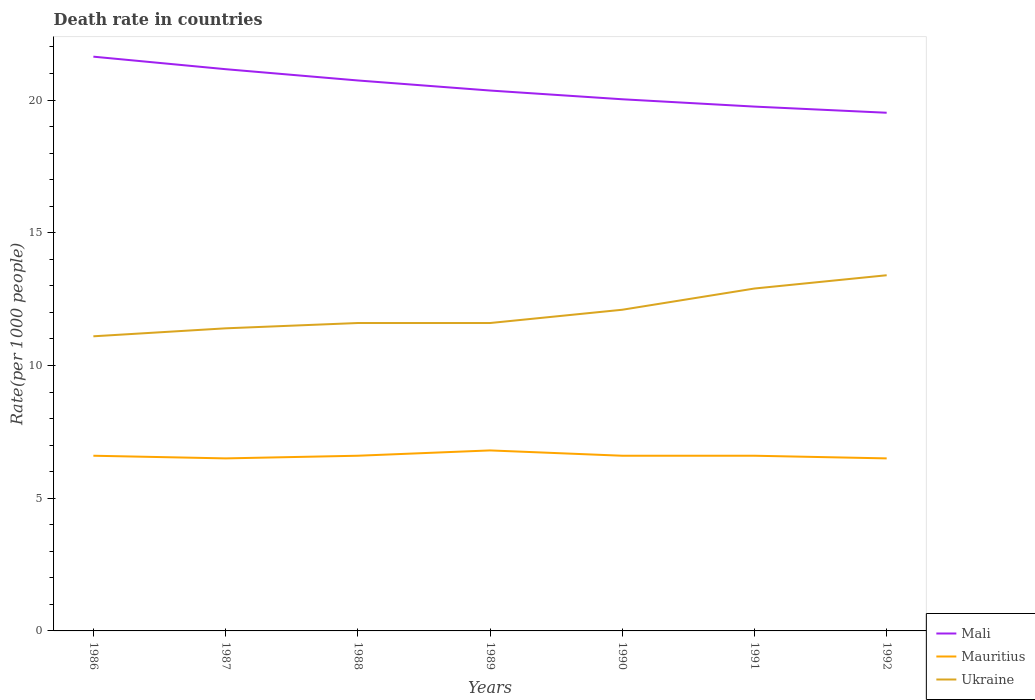Does the line corresponding to Mauritius intersect with the line corresponding to Mali?
Give a very brief answer. No. Across all years, what is the maximum death rate in Mali?
Keep it short and to the point. 19.52. In which year was the death rate in Mali maximum?
Keep it short and to the point. 1992. What is the total death rate in Mauritius in the graph?
Your answer should be very brief. 0.3. What is the difference between the highest and the second highest death rate in Mali?
Your answer should be compact. 2.11. What is the difference between two consecutive major ticks on the Y-axis?
Your answer should be very brief. 5. Are the values on the major ticks of Y-axis written in scientific E-notation?
Provide a short and direct response. No. Does the graph contain any zero values?
Your response must be concise. No. Does the graph contain grids?
Keep it short and to the point. No. Where does the legend appear in the graph?
Offer a very short reply. Bottom right. How many legend labels are there?
Ensure brevity in your answer.  3. How are the legend labels stacked?
Offer a very short reply. Vertical. What is the title of the graph?
Your answer should be compact. Death rate in countries. What is the label or title of the Y-axis?
Give a very brief answer. Rate(per 1000 people). What is the Rate(per 1000 people) of Mali in 1986?
Give a very brief answer. 21.64. What is the Rate(per 1000 people) in Ukraine in 1986?
Offer a terse response. 11.1. What is the Rate(per 1000 people) of Mali in 1987?
Make the answer very short. 21.16. What is the Rate(per 1000 people) of Mauritius in 1987?
Your answer should be very brief. 6.5. What is the Rate(per 1000 people) of Mali in 1988?
Your answer should be compact. 20.74. What is the Rate(per 1000 people) of Mauritius in 1988?
Provide a short and direct response. 6.6. What is the Rate(per 1000 people) of Ukraine in 1988?
Give a very brief answer. 11.6. What is the Rate(per 1000 people) of Mali in 1989?
Offer a very short reply. 20.36. What is the Rate(per 1000 people) of Mali in 1990?
Keep it short and to the point. 20.03. What is the Rate(per 1000 people) of Mali in 1991?
Keep it short and to the point. 19.75. What is the Rate(per 1000 people) of Mali in 1992?
Offer a very short reply. 19.52. What is the Rate(per 1000 people) of Mauritius in 1992?
Offer a very short reply. 6.5. What is the Rate(per 1000 people) in Ukraine in 1992?
Your response must be concise. 13.4. Across all years, what is the maximum Rate(per 1000 people) of Mali?
Provide a short and direct response. 21.64. Across all years, what is the maximum Rate(per 1000 people) of Mauritius?
Give a very brief answer. 6.8. Across all years, what is the maximum Rate(per 1000 people) in Ukraine?
Provide a short and direct response. 13.4. Across all years, what is the minimum Rate(per 1000 people) in Mali?
Make the answer very short. 19.52. Across all years, what is the minimum Rate(per 1000 people) of Mauritius?
Ensure brevity in your answer.  6.5. What is the total Rate(per 1000 people) in Mali in the graph?
Make the answer very short. 143.2. What is the total Rate(per 1000 people) of Mauritius in the graph?
Offer a terse response. 46.2. What is the total Rate(per 1000 people) of Ukraine in the graph?
Provide a succinct answer. 84.1. What is the difference between the Rate(per 1000 people) in Mali in 1986 and that in 1987?
Your answer should be very brief. 0.47. What is the difference between the Rate(per 1000 people) in Ukraine in 1986 and that in 1987?
Provide a short and direct response. -0.3. What is the difference between the Rate(per 1000 people) in Mali in 1986 and that in 1988?
Provide a succinct answer. 0.9. What is the difference between the Rate(per 1000 people) in Ukraine in 1986 and that in 1988?
Give a very brief answer. -0.5. What is the difference between the Rate(per 1000 people) in Mali in 1986 and that in 1989?
Your answer should be compact. 1.28. What is the difference between the Rate(per 1000 people) in Mali in 1986 and that in 1990?
Make the answer very short. 1.6. What is the difference between the Rate(per 1000 people) of Mali in 1986 and that in 1991?
Your response must be concise. 1.88. What is the difference between the Rate(per 1000 people) of Ukraine in 1986 and that in 1991?
Make the answer very short. -1.8. What is the difference between the Rate(per 1000 people) of Mali in 1986 and that in 1992?
Ensure brevity in your answer.  2.11. What is the difference between the Rate(per 1000 people) in Ukraine in 1986 and that in 1992?
Offer a very short reply. -2.3. What is the difference between the Rate(per 1000 people) in Mali in 1987 and that in 1988?
Provide a short and direct response. 0.42. What is the difference between the Rate(per 1000 people) of Mauritius in 1987 and that in 1988?
Provide a short and direct response. -0.1. What is the difference between the Rate(per 1000 people) in Mali in 1987 and that in 1989?
Offer a terse response. 0.8. What is the difference between the Rate(per 1000 people) in Mali in 1987 and that in 1990?
Offer a terse response. 1.13. What is the difference between the Rate(per 1000 people) in Mauritius in 1987 and that in 1990?
Give a very brief answer. -0.1. What is the difference between the Rate(per 1000 people) of Ukraine in 1987 and that in 1990?
Make the answer very short. -0.7. What is the difference between the Rate(per 1000 people) of Mali in 1987 and that in 1991?
Keep it short and to the point. 1.41. What is the difference between the Rate(per 1000 people) of Mauritius in 1987 and that in 1991?
Offer a terse response. -0.1. What is the difference between the Rate(per 1000 people) in Mali in 1987 and that in 1992?
Your answer should be very brief. 1.64. What is the difference between the Rate(per 1000 people) in Mauritius in 1987 and that in 1992?
Make the answer very short. 0. What is the difference between the Rate(per 1000 people) of Ukraine in 1987 and that in 1992?
Keep it short and to the point. -2. What is the difference between the Rate(per 1000 people) in Mali in 1988 and that in 1989?
Ensure brevity in your answer.  0.38. What is the difference between the Rate(per 1000 people) of Mauritius in 1988 and that in 1989?
Make the answer very short. -0.2. What is the difference between the Rate(per 1000 people) of Mali in 1988 and that in 1990?
Your answer should be compact. 0.71. What is the difference between the Rate(per 1000 people) of Mauritius in 1988 and that in 1990?
Ensure brevity in your answer.  0. What is the difference between the Rate(per 1000 people) in Ukraine in 1988 and that in 1990?
Offer a very short reply. -0.5. What is the difference between the Rate(per 1000 people) of Mauritius in 1988 and that in 1991?
Your answer should be very brief. 0. What is the difference between the Rate(per 1000 people) of Mali in 1988 and that in 1992?
Your response must be concise. 1.22. What is the difference between the Rate(per 1000 people) in Mauritius in 1988 and that in 1992?
Give a very brief answer. 0.1. What is the difference between the Rate(per 1000 people) in Mali in 1989 and that in 1990?
Provide a succinct answer. 0.33. What is the difference between the Rate(per 1000 people) in Mauritius in 1989 and that in 1990?
Make the answer very short. 0.2. What is the difference between the Rate(per 1000 people) of Mali in 1989 and that in 1991?
Your answer should be very brief. 0.6. What is the difference between the Rate(per 1000 people) in Ukraine in 1989 and that in 1991?
Keep it short and to the point. -1.3. What is the difference between the Rate(per 1000 people) in Mali in 1989 and that in 1992?
Offer a terse response. 0.84. What is the difference between the Rate(per 1000 people) in Mauritius in 1989 and that in 1992?
Offer a terse response. 0.3. What is the difference between the Rate(per 1000 people) in Ukraine in 1989 and that in 1992?
Your response must be concise. -1.8. What is the difference between the Rate(per 1000 people) of Mali in 1990 and that in 1991?
Your answer should be very brief. 0.28. What is the difference between the Rate(per 1000 people) of Mali in 1990 and that in 1992?
Your answer should be compact. 0.51. What is the difference between the Rate(per 1000 people) of Mauritius in 1990 and that in 1992?
Keep it short and to the point. 0.1. What is the difference between the Rate(per 1000 people) of Ukraine in 1990 and that in 1992?
Ensure brevity in your answer.  -1.3. What is the difference between the Rate(per 1000 people) in Mali in 1991 and that in 1992?
Give a very brief answer. 0.23. What is the difference between the Rate(per 1000 people) of Mauritius in 1991 and that in 1992?
Ensure brevity in your answer.  0.1. What is the difference between the Rate(per 1000 people) in Ukraine in 1991 and that in 1992?
Offer a very short reply. -0.5. What is the difference between the Rate(per 1000 people) in Mali in 1986 and the Rate(per 1000 people) in Mauritius in 1987?
Your response must be concise. 15.13. What is the difference between the Rate(per 1000 people) of Mali in 1986 and the Rate(per 1000 people) of Ukraine in 1987?
Your response must be concise. 10.23. What is the difference between the Rate(per 1000 people) in Mali in 1986 and the Rate(per 1000 people) in Mauritius in 1988?
Offer a terse response. 15.04. What is the difference between the Rate(per 1000 people) of Mali in 1986 and the Rate(per 1000 people) of Ukraine in 1988?
Your response must be concise. 10.04. What is the difference between the Rate(per 1000 people) of Mali in 1986 and the Rate(per 1000 people) of Mauritius in 1989?
Offer a terse response. 14.84. What is the difference between the Rate(per 1000 people) of Mali in 1986 and the Rate(per 1000 people) of Ukraine in 1989?
Keep it short and to the point. 10.04. What is the difference between the Rate(per 1000 people) in Mauritius in 1986 and the Rate(per 1000 people) in Ukraine in 1989?
Offer a very short reply. -5. What is the difference between the Rate(per 1000 people) in Mali in 1986 and the Rate(per 1000 people) in Mauritius in 1990?
Provide a short and direct response. 15.04. What is the difference between the Rate(per 1000 people) of Mali in 1986 and the Rate(per 1000 people) of Ukraine in 1990?
Make the answer very short. 9.54. What is the difference between the Rate(per 1000 people) of Mali in 1986 and the Rate(per 1000 people) of Mauritius in 1991?
Ensure brevity in your answer.  15.04. What is the difference between the Rate(per 1000 people) of Mali in 1986 and the Rate(per 1000 people) of Ukraine in 1991?
Your answer should be very brief. 8.73. What is the difference between the Rate(per 1000 people) in Mali in 1986 and the Rate(per 1000 people) in Mauritius in 1992?
Provide a succinct answer. 15.13. What is the difference between the Rate(per 1000 people) of Mali in 1986 and the Rate(per 1000 people) of Ukraine in 1992?
Keep it short and to the point. 8.23. What is the difference between the Rate(per 1000 people) of Mauritius in 1986 and the Rate(per 1000 people) of Ukraine in 1992?
Provide a short and direct response. -6.8. What is the difference between the Rate(per 1000 people) in Mali in 1987 and the Rate(per 1000 people) in Mauritius in 1988?
Ensure brevity in your answer.  14.56. What is the difference between the Rate(per 1000 people) in Mali in 1987 and the Rate(per 1000 people) in Ukraine in 1988?
Your answer should be compact. 9.56. What is the difference between the Rate(per 1000 people) in Mali in 1987 and the Rate(per 1000 people) in Mauritius in 1989?
Provide a short and direct response. 14.36. What is the difference between the Rate(per 1000 people) of Mali in 1987 and the Rate(per 1000 people) of Ukraine in 1989?
Provide a succinct answer. 9.56. What is the difference between the Rate(per 1000 people) of Mauritius in 1987 and the Rate(per 1000 people) of Ukraine in 1989?
Give a very brief answer. -5.1. What is the difference between the Rate(per 1000 people) in Mali in 1987 and the Rate(per 1000 people) in Mauritius in 1990?
Provide a short and direct response. 14.56. What is the difference between the Rate(per 1000 people) of Mali in 1987 and the Rate(per 1000 people) of Ukraine in 1990?
Your answer should be very brief. 9.06. What is the difference between the Rate(per 1000 people) of Mauritius in 1987 and the Rate(per 1000 people) of Ukraine in 1990?
Give a very brief answer. -5.6. What is the difference between the Rate(per 1000 people) of Mali in 1987 and the Rate(per 1000 people) of Mauritius in 1991?
Make the answer very short. 14.56. What is the difference between the Rate(per 1000 people) in Mali in 1987 and the Rate(per 1000 people) in Ukraine in 1991?
Your answer should be very brief. 8.26. What is the difference between the Rate(per 1000 people) in Mali in 1987 and the Rate(per 1000 people) in Mauritius in 1992?
Ensure brevity in your answer.  14.66. What is the difference between the Rate(per 1000 people) in Mali in 1987 and the Rate(per 1000 people) in Ukraine in 1992?
Keep it short and to the point. 7.76. What is the difference between the Rate(per 1000 people) in Mauritius in 1987 and the Rate(per 1000 people) in Ukraine in 1992?
Ensure brevity in your answer.  -6.9. What is the difference between the Rate(per 1000 people) in Mali in 1988 and the Rate(per 1000 people) in Mauritius in 1989?
Give a very brief answer. 13.94. What is the difference between the Rate(per 1000 people) in Mali in 1988 and the Rate(per 1000 people) in Ukraine in 1989?
Give a very brief answer. 9.14. What is the difference between the Rate(per 1000 people) of Mauritius in 1988 and the Rate(per 1000 people) of Ukraine in 1989?
Offer a terse response. -5. What is the difference between the Rate(per 1000 people) in Mali in 1988 and the Rate(per 1000 people) in Mauritius in 1990?
Provide a short and direct response. 14.14. What is the difference between the Rate(per 1000 people) in Mali in 1988 and the Rate(per 1000 people) in Ukraine in 1990?
Your answer should be compact. 8.64. What is the difference between the Rate(per 1000 people) of Mali in 1988 and the Rate(per 1000 people) of Mauritius in 1991?
Your answer should be compact. 14.14. What is the difference between the Rate(per 1000 people) in Mali in 1988 and the Rate(per 1000 people) in Ukraine in 1991?
Provide a short and direct response. 7.84. What is the difference between the Rate(per 1000 people) of Mauritius in 1988 and the Rate(per 1000 people) of Ukraine in 1991?
Offer a terse response. -6.3. What is the difference between the Rate(per 1000 people) of Mali in 1988 and the Rate(per 1000 people) of Mauritius in 1992?
Your response must be concise. 14.24. What is the difference between the Rate(per 1000 people) in Mali in 1988 and the Rate(per 1000 people) in Ukraine in 1992?
Give a very brief answer. 7.34. What is the difference between the Rate(per 1000 people) of Mali in 1989 and the Rate(per 1000 people) of Mauritius in 1990?
Make the answer very short. 13.76. What is the difference between the Rate(per 1000 people) of Mali in 1989 and the Rate(per 1000 people) of Ukraine in 1990?
Keep it short and to the point. 8.26. What is the difference between the Rate(per 1000 people) in Mali in 1989 and the Rate(per 1000 people) in Mauritius in 1991?
Your response must be concise. 13.76. What is the difference between the Rate(per 1000 people) of Mali in 1989 and the Rate(per 1000 people) of Ukraine in 1991?
Ensure brevity in your answer.  7.46. What is the difference between the Rate(per 1000 people) in Mali in 1989 and the Rate(per 1000 people) in Mauritius in 1992?
Make the answer very short. 13.86. What is the difference between the Rate(per 1000 people) of Mali in 1989 and the Rate(per 1000 people) of Ukraine in 1992?
Provide a short and direct response. 6.96. What is the difference between the Rate(per 1000 people) of Mauritius in 1989 and the Rate(per 1000 people) of Ukraine in 1992?
Your answer should be compact. -6.6. What is the difference between the Rate(per 1000 people) of Mali in 1990 and the Rate(per 1000 people) of Mauritius in 1991?
Give a very brief answer. 13.43. What is the difference between the Rate(per 1000 people) of Mali in 1990 and the Rate(per 1000 people) of Ukraine in 1991?
Your answer should be compact. 7.13. What is the difference between the Rate(per 1000 people) of Mauritius in 1990 and the Rate(per 1000 people) of Ukraine in 1991?
Provide a succinct answer. -6.3. What is the difference between the Rate(per 1000 people) in Mali in 1990 and the Rate(per 1000 people) in Mauritius in 1992?
Keep it short and to the point. 13.53. What is the difference between the Rate(per 1000 people) in Mali in 1990 and the Rate(per 1000 people) in Ukraine in 1992?
Your answer should be compact. 6.63. What is the difference between the Rate(per 1000 people) in Mauritius in 1990 and the Rate(per 1000 people) in Ukraine in 1992?
Give a very brief answer. -6.8. What is the difference between the Rate(per 1000 people) of Mali in 1991 and the Rate(per 1000 people) of Mauritius in 1992?
Your answer should be very brief. 13.25. What is the difference between the Rate(per 1000 people) of Mali in 1991 and the Rate(per 1000 people) of Ukraine in 1992?
Your response must be concise. 6.35. What is the average Rate(per 1000 people) in Mali per year?
Your answer should be very brief. 20.46. What is the average Rate(per 1000 people) in Ukraine per year?
Your answer should be compact. 12.01. In the year 1986, what is the difference between the Rate(per 1000 people) in Mali and Rate(per 1000 people) in Mauritius?
Keep it short and to the point. 15.04. In the year 1986, what is the difference between the Rate(per 1000 people) in Mali and Rate(per 1000 people) in Ukraine?
Your answer should be compact. 10.54. In the year 1986, what is the difference between the Rate(per 1000 people) in Mauritius and Rate(per 1000 people) in Ukraine?
Provide a short and direct response. -4.5. In the year 1987, what is the difference between the Rate(per 1000 people) of Mali and Rate(per 1000 people) of Mauritius?
Provide a short and direct response. 14.66. In the year 1987, what is the difference between the Rate(per 1000 people) of Mali and Rate(per 1000 people) of Ukraine?
Provide a succinct answer. 9.76. In the year 1988, what is the difference between the Rate(per 1000 people) of Mali and Rate(per 1000 people) of Mauritius?
Make the answer very short. 14.14. In the year 1988, what is the difference between the Rate(per 1000 people) of Mali and Rate(per 1000 people) of Ukraine?
Your response must be concise. 9.14. In the year 1988, what is the difference between the Rate(per 1000 people) in Mauritius and Rate(per 1000 people) in Ukraine?
Ensure brevity in your answer.  -5. In the year 1989, what is the difference between the Rate(per 1000 people) in Mali and Rate(per 1000 people) in Mauritius?
Offer a very short reply. 13.56. In the year 1989, what is the difference between the Rate(per 1000 people) in Mali and Rate(per 1000 people) in Ukraine?
Give a very brief answer. 8.76. In the year 1989, what is the difference between the Rate(per 1000 people) of Mauritius and Rate(per 1000 people) of Ukraine?
Ensure brevity in your answer.  -4.8. In the year 1990, what is the difference between the Rate(per 1000 people) in Mali and Rate(per 1000 people) in Mauritius?
Your answer should be very brief. 13.43. In the year 1990, what is the difference between the Rate(per 1000 people) in Mali and Rate(per 1000 people) in Ukraine?
Your response must be concise. 7.93. In the year 1991, what is the difference between the Rate(per 1000 people) of Mali and Rate(per 1000 people) of Mauritius?
Provide a short and direct response. 13.15. In the year 1991, what is the difference between the Rate(per 1000 people) of Mali and Rate(per 1000 people) of Ukraine?
Provide a succinct answer. 6.85. In the year 1992, what is the difference between the Rate(per 1000 people) in Mali and Rate(per 1000 people) in Mauritius?
Your response must be concise. 13.02. In the year 1992, what is the difference between the Rate(per 1000 people) of Mali and Rate(per 1000 people) of Ukraine?
Provide a short and direct response. 6.12. In the year 1992, what is the difference between the Rate(per 1000 people) of Mauritius and Rate(per 1000 people) of Ukraine?
Your answer should be very brief. -6.9. What is the ratio of the Rate(per 1000 people) of Mali in 1986 to that in 1987?
Provide a succinct answer. 1.02. What is the ratio of the Rate(per 1000 people) in Mauritius in 1986 to that in 1987?
Give a very brief answer. 1.02. What is the ratio of the Rate(per 1000 people) in Ukraine in 1986 to that in 1987?
Offer a terse response. 0.97. What is the ratio of the Rate(per 1000 people) of Mali in 1986 to that in 1988?
Ensure brevity in your answer.  1.04. What is the ratio of the Rate(per 1000 people) in Mauritius in 1986 to that in 1988?
Offer a terse response. 1. What is the ratio of the Rate(per 1000 people) in Ukraine in 1986 to that in 1988?
Provide a short and direct response. 0.96. What is the ratio of the Rate(per 1000 people) in Mali in 1986 to that in 1989?
Provide a short and direct response. 1.06. What is the ratio of the Rate(per 1000 people) in Mauritius in 1986 to that in 1989?
Your answer should be compact. 0.97. What is the ratio of the Rate(per 1000 people) in Ukraine in 1986 to that in 1989?
Offer a very short reply. 0.96. What is the ratio of the Rate(per 1000 people) of Mali in 1986 to that in 1990?
Your answer should be very brief. 1.08. What is the ratio of the Rate(per 1000 people) of Ukraine in 1986 to that in 1990?
Keep it short and to the point. 0.92. What is the ratio of the Rate(per 1000 people) of Mali in 1986 to that in 1991?
Your answer should be compact. 1.1. What is the ratio of the Rate(per 1000 people) of Mauritius in 1986 to that in 1991?
Keep it short and to the point. 1. What is the ratio of the Rate(per 1000 people) of Ukraine in 1986 to that in 1991?
Your response must be concise. 0.86. What is the ratio of the Rate(per 1000 people) in Mali in 1986 to that in 1992?
Your answer should be compact. 1.11. What is the ratio of the Rate(per 1000 people) in Mauritius in 1986 to that in 1992?
Give a very brief answer. 1.02. What is the ratio of the Rate(per 1000 people) of Ukraine in 1986 to that in 1992?
Give a very brief answer. 0.83. What is the ratio of the Rate(per 1000 people) in Mali in 1987 to that in 1988?
Your answer should be compact. 1.02. What is the ratio of the Rate(per 1000 people) in Ukraine in 1987 to that in 1988?
Provide a succinct answer. 0.98. What is the ratio of the Rate(per 1000 people) in Mali in 1987 to that in 1989?
Your answer should be very brief. 1.04. What is the ratio of the Rate(per 1000 people) in Mauritius in 1987 to that in 1989?
Offer a very short reply. 0.96. What is the ratio of the Rate(per 1000 people) in Ukraine in 1987 to that in 1989?
Keep it short and to the point. 0.98. What is the ratio of the Rate(per 1000 people) of Mali in 1987 to that in 1990?
Ensure brevity in your answer.  1.06. What is the ratio of the Rate(per 1000 people) of Ukraine in 1987 to that in 1990?
Your response must be concise. 0.94. What is the ratio of the Rate(per 1000 people) in Mali in 1987 to that in 1991?
Provide a succinct answer. 1.07. What is the ratio of the Rate(per 1000 people) in Mauritius in 1987 to that in 1991?
Ensure brevity in your answer.  0.98. What is the ratio of the Rate(per 1000 people) of Ukraine in 1987 to that in 1991?
Your answer should be very brief. 0.88. What is the ratio of the Rate(per 1000 people) of Mali in 1987 to that in 1992?
Your response must be concise. 1.08. What is the ratio of the Rate(per 1000 people) of Mauritius in 1987 to that in 1992?
Keep it short and to the point. 1. What is the ratio of the Rate(per 1000 people) in Ukraine in 1987 to that in 1992?
Offer a very short reply. 0.85. What is the ratio of the Rate(per 1000 people) of Mali in 1988 to that in 1989?
Give a very brief answer. 1.02. What is the ratio of the Rate(per 1000 people) of Mauritius in 1988 to that in 1989?
Ensure brevity in your answer.  0.97. What is the ratio of the Rate(per 1000 people) in Mali in 1988 to that in 1990?
Keep it short and to the point. 1.04. What is the ratio of the Rate(per 1000 people) in Mauritius in 1988 to that in 1990?
Provide a succinct answer. 1. What is the ratio of the Rate(per 1000 people) in Ukraine in 1988 to that in 1990?
Make the answer very short. 0.96. What is the ratio of the Rate(per 1000 people) in Mali in 1988 to that in 1991?
Make the answer very short. 1.05. What is the ratio of the Rate(per 1000 people) in Ukraine in 1988 to that in 1991?
Your response must be concise. 0.9. What is the ratio of the Rate(per 1000 people) in Mali in 1988 to that in 1992?
Your answer should be very brief. 1.06. What is the ratio of the Rate(per 1000 people) of Mauritius in 1988 to that in 1992?
Your answer should be very brief. 1.02. What is the ratio of the Rate(per 1000 people) in Ukraine in 1988 to that in 1992?
Your response must be concise. 0.87. What is the ratio of the Rate(per 1000 people) in Mali in 1989 to that in 1990?
Your answer should be very brief. 1.02. What is the ratio of the Rate(per 1000 people) of Mauritius in 1989 to that in 1990?
Ensure brevity in your answer.  1.03. What is the ratio of the Rate(per 1000 people) of Ukraine in 1989 to that in 1990?
Offer a terse response. 0.96. What is the ratio of the Rate(per 1000 people) in Mali in 1989 to that in 1991?
Make the answer very short. 1.03. What is the ratio of the Rate(per 1000 people) of Mauritius in 1989 to that in 1991?
Your answer should be very brief. 1.03. What is the ratio of the Rate(per 1000 people) in Ukraine in 1989 to that in 1991?
Provide a short and direct response. 0.9. What is the ratio of the Rate(per 1000 people) of Mali in 1989 to that in 1992?
Provide a short and direct response. 1.04. What is the ratio of the Rate(per 1000 people) of Mauritius in 1989 to that in 1992?
Your answer should be very brief. 1.05. What is the ratio of the Rate(per 1000 people) of Ukraine in 1989 to that in 1992?
Ensure brevity in your answer.  0.87. What is the ratio of the Rate(per 1000 people) of Ukraine in 1990 to that in 1991?
Give a very brief answer. 0.94. What is the ratio of the Rate(per 1000 people) in Mali in 1990 to that in 1992?
Your answer should be very brief. 1.03. What is the ratio of the Rate(per 1000 people) of Mauritius in 1990 to that in 1992?
Provide a short and direct response. 1.02. What is the ratio of the Rate(per 1000 people) in Ukraine in 1990 to that in 1992?
Your answer should be very brief. 0.9. What is the ratio of the Rate(per 1000 people) in Mali in 1991 to that in 1992?
Your answer should be compact. 1.01. What is the ratio of the Rate(per 1000 people) in Mauritius in 1991 to that in 1992?
Give a very brief answer. 1.02. What is the ratio of the Rate(per 1000 people) of Ukraine in 1991 to that in 1992?
Offer a very short reply. 0.96. What is the difference between the highest and the second highest Rate(per 1000 people) in Mali?
Keep it short and to the point. 0.47. What is the difference between the highest and the second highest Rate(per 1000 people) of Mauritius?
Offer a very short reply. 0.2. What is the difference between the highest and the lowest Rate(per 1000 people) in Mali?
Offer a very short reply. 2.11. What is the difference between the highest and the lowest Rate(per 1000 people) in Ukraine?
Ensure brevity in your answer.  2.3. 